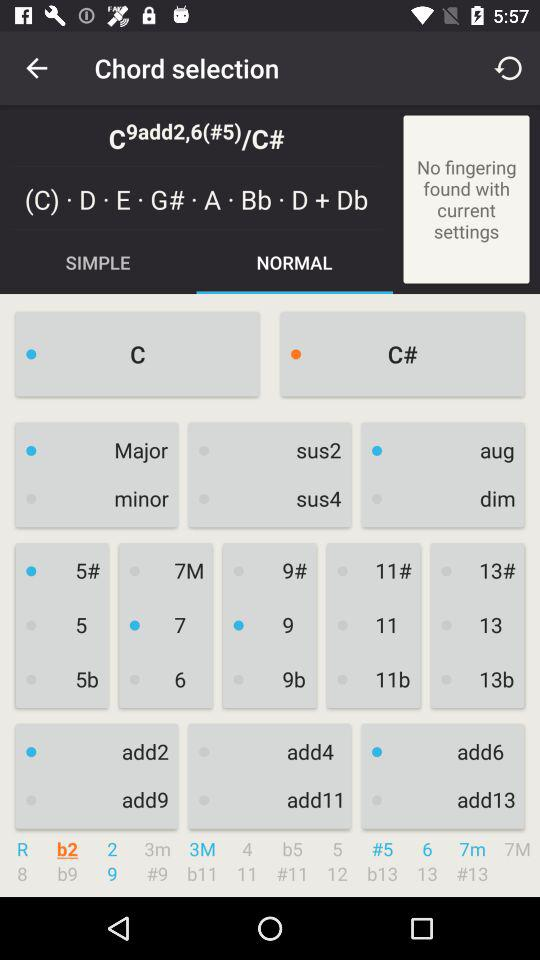Which option is selected? The selected option is "NORMAL". 